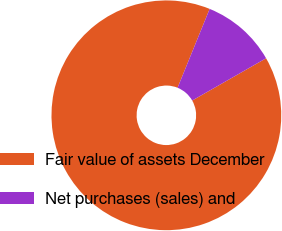Convert chart to OTSL. <chart><loc_0><loc_0><loc_500><loc_500><pie_chart><fcel>Fair value of assets December<fcel>Net purchases (sales) and<nl><fcel>89.42%<fcel>10.58%<nl></chart> 